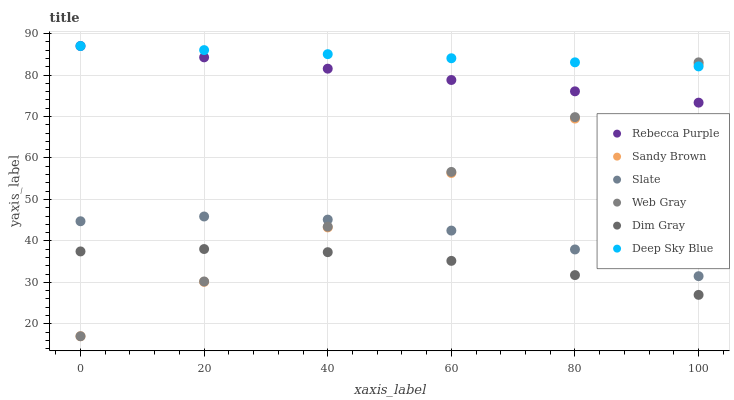Does Dim Gray have the minimum area under the curve?
Answer yes or no. Yes. Does Deep Sky Blue have the maximum area under the curve?
Answer yes or no. Yes. Does Slate have the minimum area under the curve?
Answer yes or no. No. Does Slate have the maximum area under the curve?
Answer yes or no. No. Is Sandy Brown the smoothest?
Answer yes or no. Yes. Is Slate the roughest?
Answer yes or no. Yes. Is Dim Gray the smoothest?
Answer yes or no. No. Is Dim Gray the roughest?
Answer yes or no. No. Does Web Gray have the lowest value?
Answer yes or no. Yes. Does Slate have the lowest value?
Answer yes or no. No. Does Deep Sky Blue have the highest value?
Answer yes or no. Yes. Does Slate have the highest value?
Answer yes or no. No. Is Dim Gray less than Rebecca Purple?
Answer yes or no. Yes. Is Slate greater than Dim Gray?
Answer yes or no. Yes. Does Dim Gray intersect Web Gray?
Answer yes or no. Yes. Is Dim Gray less than Web Gray?
Answer yes or no. No. Is Dim Gray greater than Web Gray?
Answer yes or no. No. Does Dim Gray intersect Rebecca Purple?
Answer yes or no. No. 